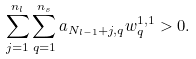<formula> <loc_0><loc_0><loc_500><loc_500>\sum _ { j = 1 } ^ { n _ { l } } \sum _ { q = 1 } ^ { n _ { s } } a _ { N _ { l - 1 } + j , q } w ^ { 1 , 1 } _ { q } > 0 .</formula> 